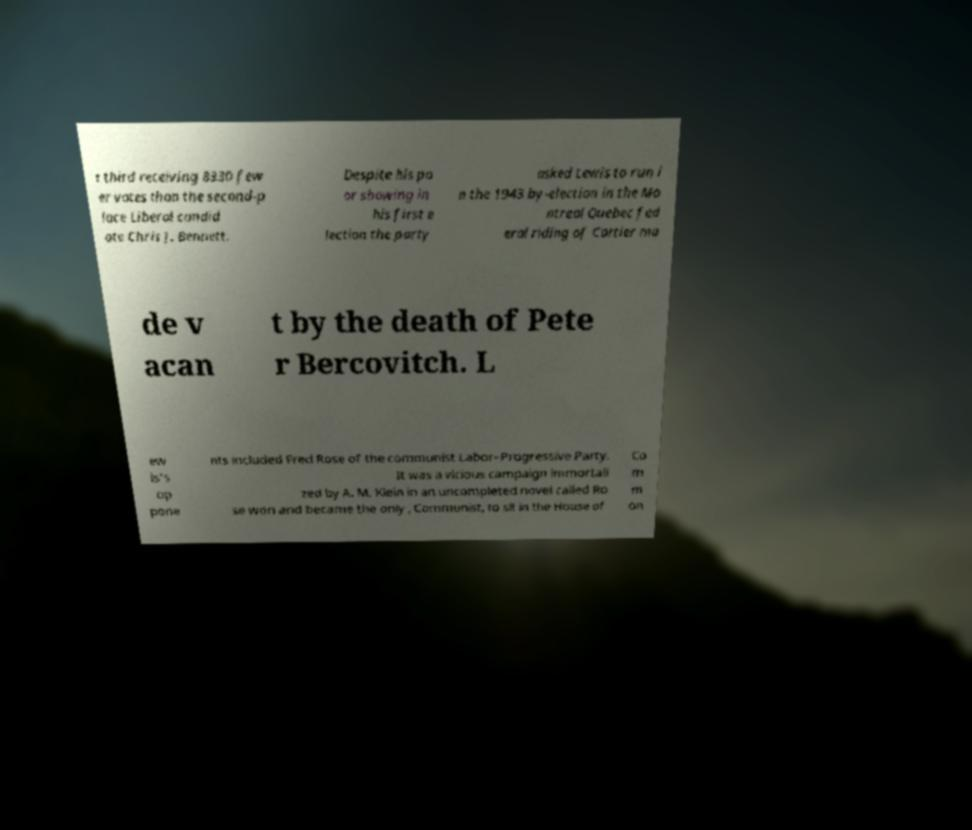Please identify and transcribe the text found in this image. t third receiving 8330 few er votes than the second-p lace Liberal candid ate Chris J. Bennett. Despite his po or showing in his first e lection the party asked Lewis to run i n the 1943 by-election in the Mo ntreal Quebec fed eral riding of Cartier ma de v acan t by the death of Pete r Bercovitch. L ew is's op pone nts included Fred Rose of the communist Labor–Progressive Party. It was a vicious campaign immortali zed by A. M. Klein in an uncompleted novel called Ro se won and became the only , Communist, to sit in the House of Co m m on 